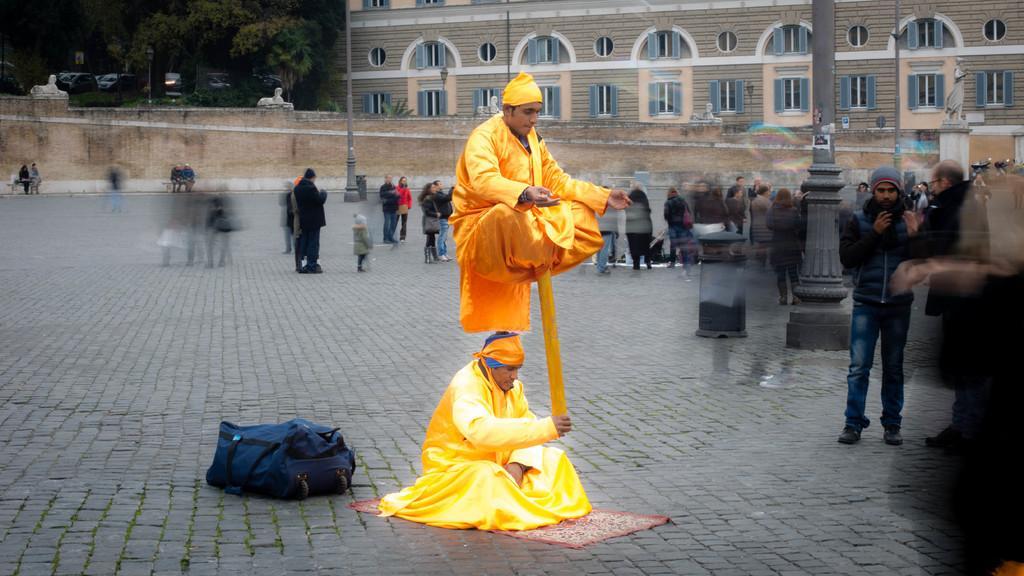Can you describe this image briefly? In the image two people were performing some activity and around them there are many other people standing on the ground and most of the picture was blurred. In the background there is a building and on the left side of the building there are many trees and few vehicles. 